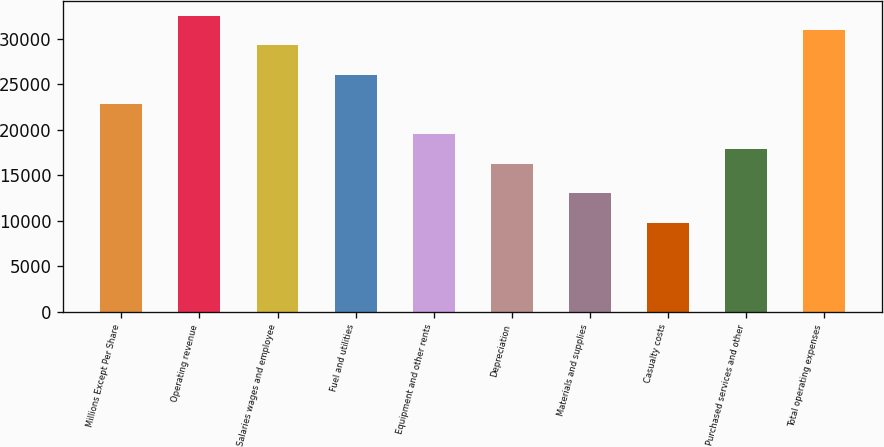Convert chart to OTSL. <chart><loc_0><loc_0><loc_500><loc_500><bar_chart><fcel>Millions Except Per Share<fcel>Operating revenue<fcel>Salaries wages and employee<fcel>Fuel and utilities<fcel>Equipment and other rents<fcel>Depreciation<fcel>Materials and supplies<fcel>Casualty costs<fcel>Purchased services and other<fcel>Total operating expenses<nl><fcel>22795.6<fcel>32564.5<fcel>29308.2<fcel>26051.9<fcel>19539.3<fcel>16283<fcel>13026.7<fcel>9770.39<fcel>17911.1<fcel>30936.3<nl></chart> 